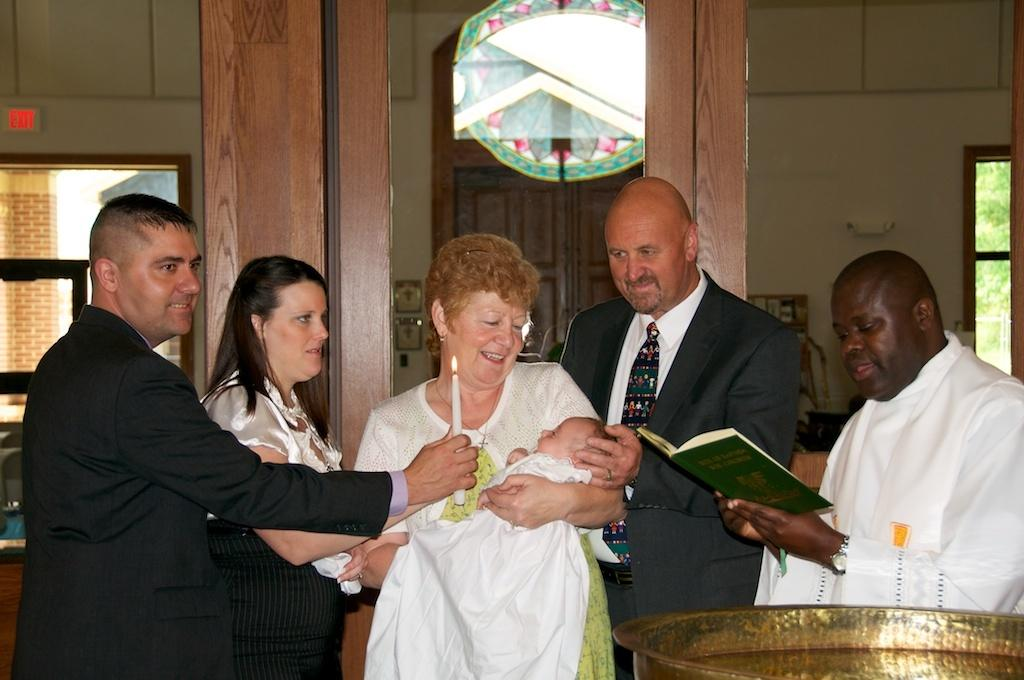How many people are present in the image? There are five persons standing in the image. What is one person doing with a baby? One person is carrying a baby. What object is held by one of the persons? One person is holding a book. What is another person holding in the image? One person is holding a candle. What can be seen in the background of the image? There are windows and a door in the background of the image. What type of lock is visible on the frame of the door in the image? There is no lock visible on the frame of the door in the image. What route are the persons taking in the image? The image does not show the persons taking any specific route; they are standing still. 